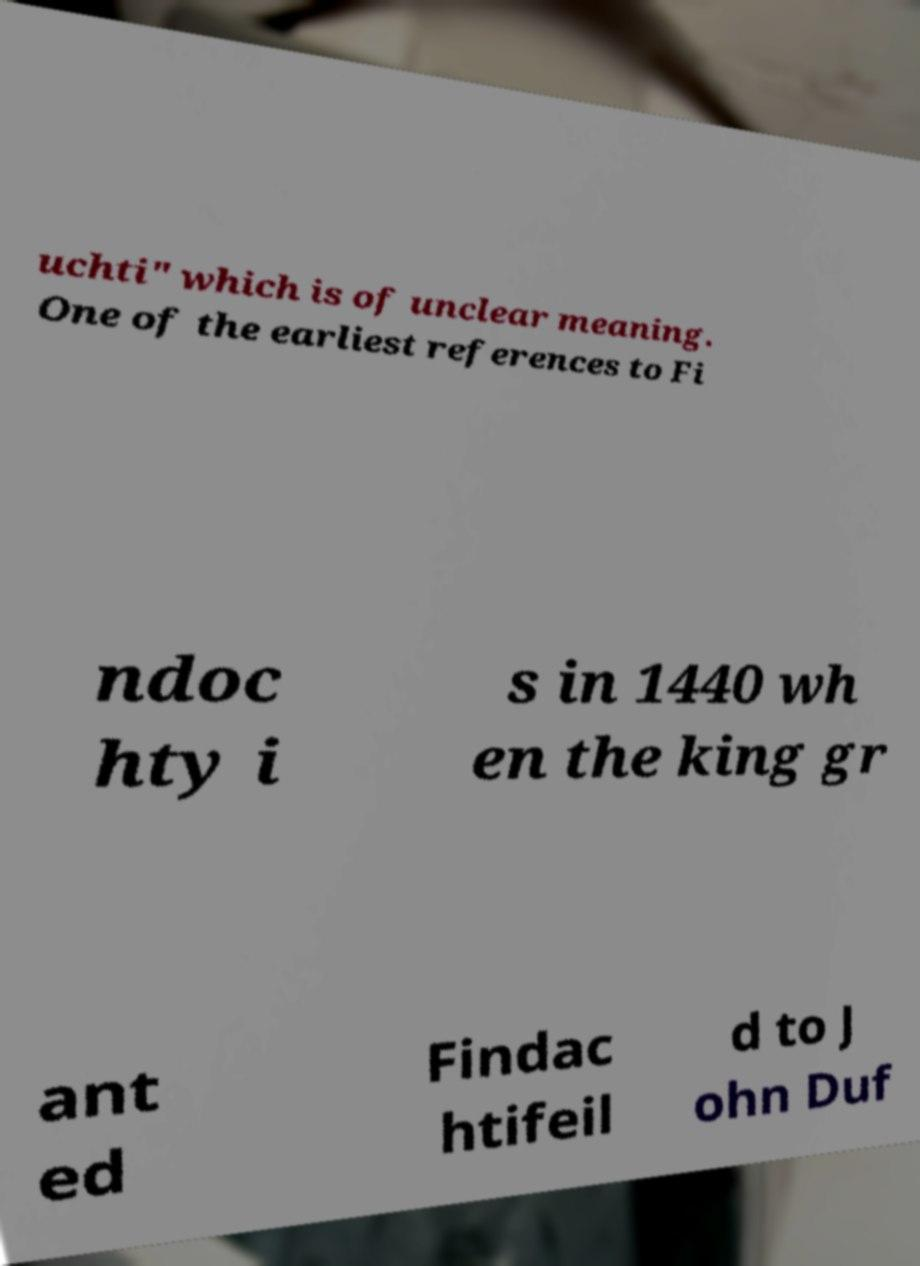There's text embedded in this image that I need extracted. Can you transcribe it verbatim? uchti" which is of unclear meaning. One of the earliest references to Fi ndoc hty i s in 1440 wh en the king gr ant ed Findac htifeil d to J ohn Duf 